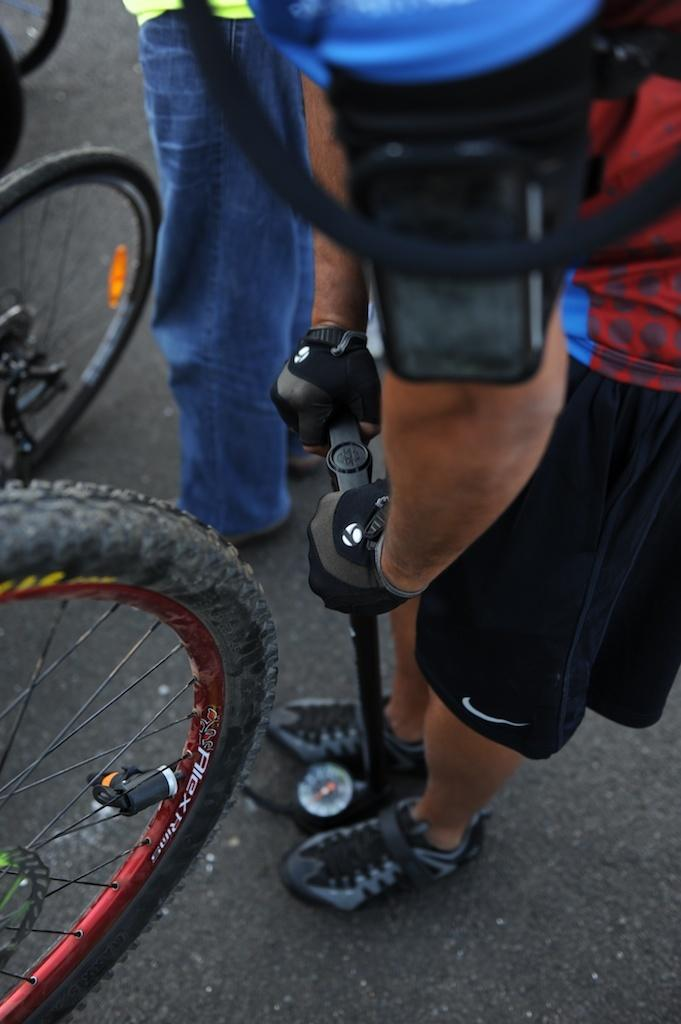What is the person in the image holding? The person is holding a cycle pump in the image. What can be seen on the road in the image? There are bicycles on the road in the image. Are there any other people present in the image? Yes, there is another person standing on the road in the image. What type of dolls can be seen swimming in the image? There are no dolls or swimming activities present in the image. 